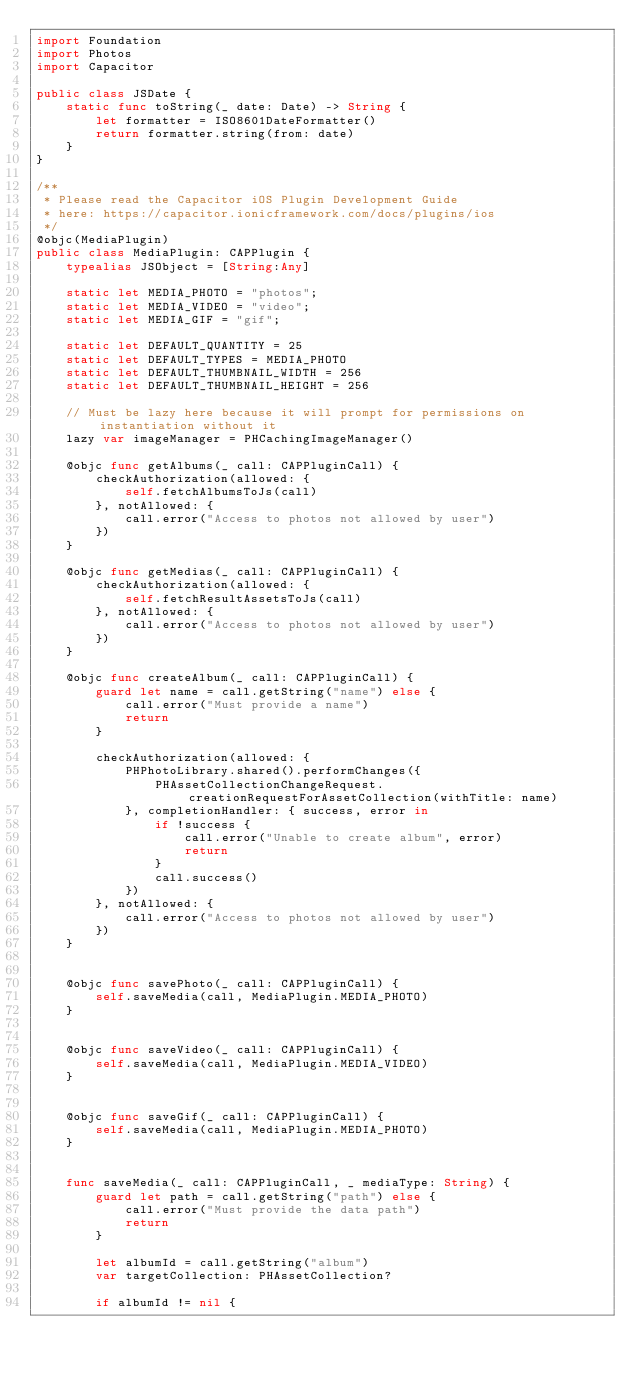Convert code to text. <code><loc_0><loc_0><loc_500><loc_500><_Swift_>import Foundation
import Photos
import Capacitor

public class JSDate {
    static func toString(_ date: Date) -> String {
        let formatter = ISO8601DateFormatter()
        return formatter.string(from: date)
    }
}

/**
 * Please read the Capacitor iOS Plugin Development Guide
 * here: https://capacitor.ionicframework.com/docs/plugins/ios
 */
@objc(MediaPlugin)
public class MediaPlugin: CAPPlugin {
    typealias JSObject = [String:Any]

    static let MEDIA_PHOTO = "photos";
    static let MEDIA_VIDEO = "video";
    static let MEDIA_GIF = "gif";
    
    static let DEFAULT_QUANTITY = 25
    static let DEFAULT_TYPES = MEDIA_PHOTO
    static let DEFAULT_THUMBNAIL_WIDTH = 256
    static let DEFAULT_THUMBNAIL_HEIGHT = 256
    
    // Must be lazy here because it will prompt for permissions on instantiation without it
    lazy var imageManager = PHCachingImageManager()
    
    @objc func getAlbums(_ call: CAPPluginCall) {
        checkAuthorization(allowed: {
            self.fetchAlbumsToJs(call)
        }, notAllowed: {
            call.error("Access to photos not allowed by user")
        })
    }
    
    @objc func getMedias(_ call: CAPPluginCall) {
        checkAuthorization(allowed: {
            self.fetchResultAssetsToJs(call)
        }, notAllowed: {
            call.error("Access to photos not allowed by user")
        })
    }
    
    @objc func createAlbum(_ call: CAPPluginCall) {
        guard let name = call.getString("name") else {
            call.error("Must provide a name")
            return
        }
        
        checkAuthorization(allowed: {
            PHPhotoLibrary.shared().performChanges({
                PHAssetCollectionChangeRequest.creationRequestForAssetCollection(withTitle: name)
            }, completionHandler: { success, error in
                if !success {
                    call.error("Unable to create album", error)
                    return
                }
                call.success()
            })
        }, notAllowed: {
            call.error("Access to photos not allowed by user")
        })
    }

    
    @objc func savePhoto(_ call: CAPPluginCall) {
        self.saveMedia(call, MediaPlugin.MEDIA_PHOTO)
    }
  
    
    @objc func saveVideo(_ call: CAPPluginCall) {
        self.saveMedia(call, MediaPlugin.MEDIA_VIDEO)
    }

    
    @objc func saveGif(_ call: CAPPluginCall) {
        self.saveMedia(call, MediaPlugin.MEDIA_PHOTO)
    }
    

    func saveMedia(_ call: CAPPluginCall, _ mediaType: String) {
        guard let path = call.getString("path") else {
            call.error("Must provide the data path")
            return
        }
        
        let albumId = call.getString("album")
        var targetCollection: PHAssetCollection?
        
        if albumId != nil {</code> 